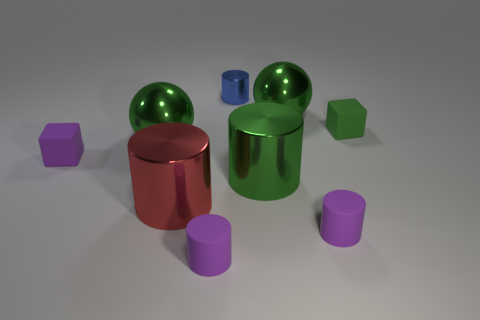Subtract all gray cylinders. Subtract all gray spheres. How many cylinders are left? 5 Add 1 gray rubber objects. How many objects exist? 10 Subtract all cylinders. How many objects are left? 4 Subtract 1 green cylinders. How many objects are left? 8 Subtract all purple rubber objects. Subtract all blue shiny cylinders. How many objects are left? 5 Add 7 purple objects. How many purple objects are left? 10 Add 9 small purple blocks. How many small purple blocks exist? 10 